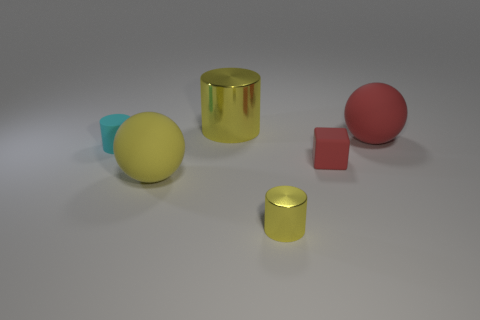The shiny thing behind the yellow ball that is in front of the tiny matte cylinder is what shape?
Ensure brevity in your answer.  Cylinder. Do the tiny rubber cylinder and the tiny metal object have the same color?
Offer a very short reply. No. What number of brown objects are tiny rubber things or cubes?
Give a very brief answer. 0. Are there any cyan cylinders behind the large yellow metal cylinder?
Make the answer very short. No. The cyan cylinder has what size?
Your response must be concise. Small. The other yellow object that is the same shape as the tiny shiny object is what size?
Your answer should be very brief. Large. How many yellow shiny cylinders are in front of the large metal object that is behind the tiny cyan rubber cylinder?
Provide a short and direct response. 1. Is the material of the sphere behind the tiny red block the same as the cylinder to the right of the big yellow shiny object?
Your response must be concise. No. How many other cyan objects are the same shape as the small metallic thing?
Your answer should be very brief. 1. How many other cylinders are the same color as the matte cylinder?
Provide a succinct answer. 0. 